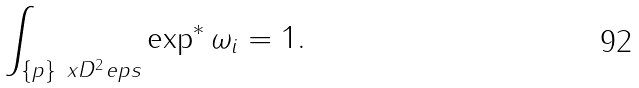Convert formula to latex. <formula><loc_0><loc_0><loc_500><loc_500>\int _ { \{ p \} \ x D ^ { 2 } _ { \ } e p s } \exp ^ { * } \omega _ { i } = 1 .</formula> 